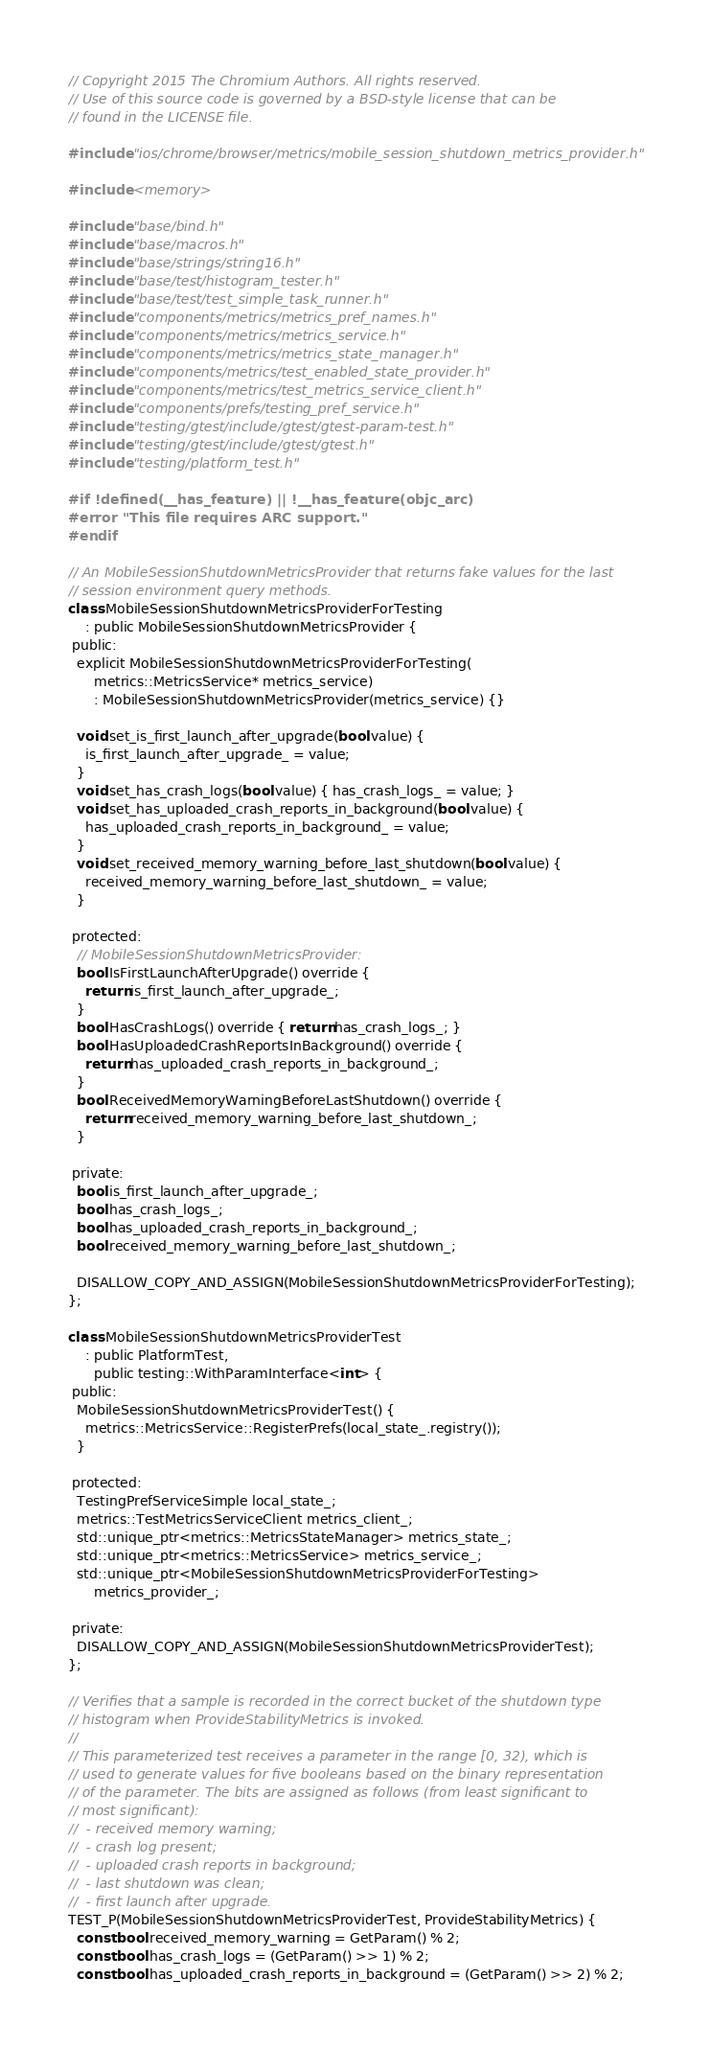<code> <loc_0><loc_0><loc_500><loc_500><_ObjectiveC_>// Copyright 2015 The Chromium Authors. All rights reserved.
// Use of this source code is governed by a BSD-style license that can be
// found in the LICENSE file.

#include "ios/chrome/browser/metrics/mobile_session_shutdown_metrics_provider.h"

#include <memory>

#include "base/bind.h"
#include "base/macros.h"
#include "base/strings/string16.h"
#include "base/test/histogram_tester.h"
#include "base/test/test_simple_task_runner.h"
#include "components/metrics/metrics_pref_names.h"
#include "components/metrics/metrics_service.h"
#include "components/metrics/metrics_state_manager.h"
#include "components/metrics/test_enabled_state_provider.h"
#include "components/metrics/test_metrics_service_client.h"
#include "components/prefs/testing_pref_service.h"
#include "testing/gtest/include/gtest/gtest-param-test.h"
#include "testing/gtest/include/gtest/gtest.h"
#include "testing/platform_test.h"

#if !defined(__has_feature) || !__has_feature(objc_arc)
#error "This file requires ARC support."
#endif

// An MobileSessionShutdownMetricsProvider that returns fake values for the last
// session environment query methods.
class MobileSessionShutdownMetricsProviderForTesting
    : public MobileSessionShutdownMetricsProvider {
 public:
  explicit MobileSessionShutdownMetricsProviderForTesting(
      metrics::MetricsService* metrics_service)
      : MobileSessionShutdownMetricsProvider(metrics_service) {}

  void set_is_first_launch_after_upgrade(bool value) {
    is_first_launch_after_upgrade_ = value;
  }
  void set_has_crash_logs(bool value) { has_crash_logs_ = value; }
  void set_has_uploaded_crash_reports_in_background(bool value) {
    has_uploaded_crash_reports_in_background_ = value;
  }
  void set_received_memory_warning_before_last_shutdown(bool value) {
    received_memory_warning_before_last_shutdown_ = value;
  }

 protected:
  // MobileSessionShutdownMetricsProvider:
  bool IsFirstLaunchAfterUpgrade() override {
    return is_first_launch_after_upgrade_;
  }
  bool HasCrashLogs() override { return has_crash_logs_; }
  bool HasUploadedCrashReportsInBackground() override {
    return has_uploaded_crash_reports_in_background_;
  }
  bool ReceivedMemoryWarningBeforeLastShutdown() override {
    return received_memory_warning_before_last_shutdown_;
  }

 private:
  bool is_first_launch_after_upgrade_;
  bool has_crash_logs_;
  bool has_uploaded_crash_reports_in_background_;
  bool received_memory_warning_before_last_shutdown_;

  DISALLOW_COPY_AND_ASSIGN(MobileSessionShutdownMetricsProviderForTesting);
};

class MobileSessionShutdownMetricsProviderTest
    : public PlatformTest,
      public testing::WithParamInterface<int> {
 public:
  MobileSessionShutdownMetricsProviderTest() {
    metrics::MetricsService::RegisterPrefs(local_state_.registry());
  }

 protected:
  TestingPrefServiceSimple local_state_;
  metrics::TestMetricsServiceClient metrics_client_;
  std::unique_ptr<metrics::MetricsStateManager> metrics_state_;
  std::unique_ptr<metrics::MetricsService> metrics_service_;
  std::unique_ptr<MobileSessionShutdownMetricsProviderForTesting>
      metrics_provider_;

 private:
  DISALLOW_COPY_AND_ASSIGN(MobileSessionShutdownMetricsProviderTest);
};

// Verifies that a sample is recorded in the correct bucket of the shutdown type
// histogram when ProvideStabilityMetrics is invoked.
//
// This parameterized test receives a parameter in the range [0, 32), which is
// used to generate values for five booleans based on the binary representation
// of the parameter. The bits are assigned as follows (from least significant to
// most significant):
//  - received memory warning;
//  - crash log present;
//  - uploaded crash reports in background;
//  - last shutdown was clean;
//  - first launch after upgrade.
TEST_P(MobileSessionShutdownMetricsProviderTest, ProvideStabilityMetrics) {
  const bool received_memory_warning = GetParam() % 2;
  const bool has_crash_logs = (GetParam() >> 1) % 2;
  const bool has_uploaded_crash_reports_in_background = (GetParam() >> 2) % 2;</code> 